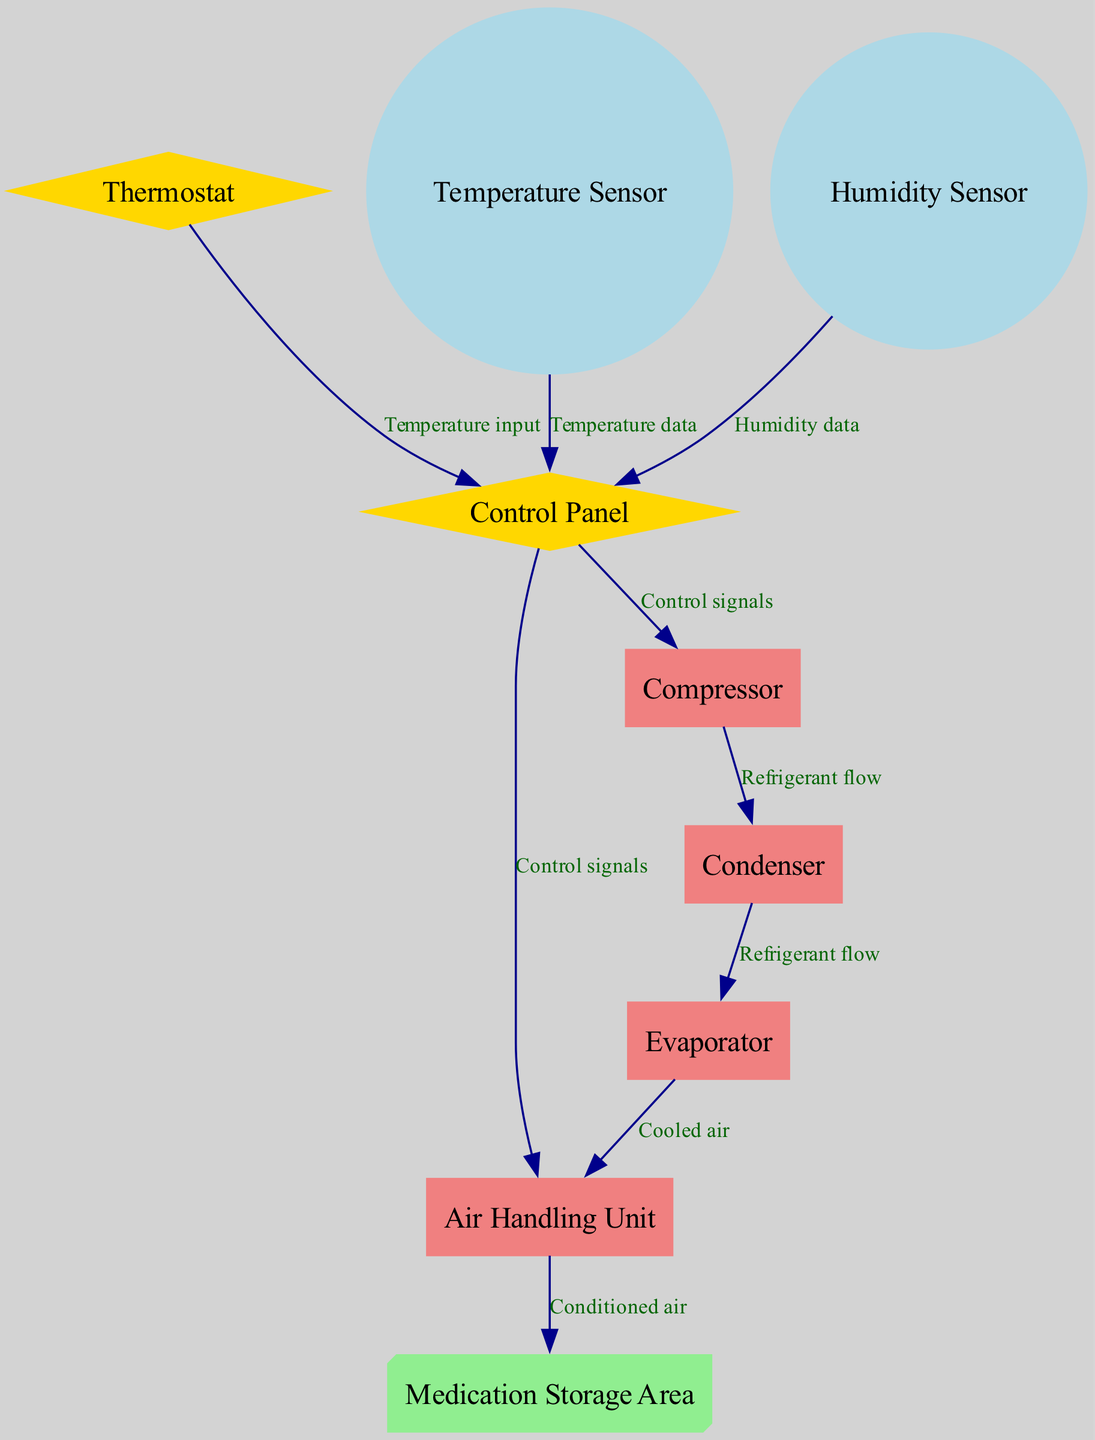What are the shapes of the Thermostat and Control Panel nodes? The Thermostat and Control Panel nodes are both represented as diamond shapes, which typically indicate decision points or controls in a diagram. This can be observed directly from the diagram where specific attributes are assigned to these nodes.
Answer: diamond How many edges are coming out of the Control Panel? The Control Panel node has two edges coming out of it: one towards the Air Handling Unit and one towards the Compressor. This can be counted directly from the diagram.
Answer: 2 What type of sensor is connected to the Control Panel? The Control Panel is connected to two types of sensors: the Temperature Sensor and the Humidity Sensor. The relationship can be determined by following the edges from both sensors to the Control Panel in the diagram.
Answer: Temperature Sensor and Humidity Sensor What is the flow of refrigerant starting from the Compressor? The flow of refrigerant starts at the Compressor and moves to the Condenser, then from the Condenser to the Evaporator. This follows the edges outlined in the diagram, highlighting the path of refrigerant clearly.
Answer: Compressor to Condenser to Evaporator Which node receives conditioned air directly? The Medication Storage Area receives conditioned air directly from the Air Handling Unit, as indicated by the edge connecting these two nodes in the diagram.
Answer: Medication Storage Area How many nodes are there in total? There are a total of nine nodes in the diagram, which can be verified by counting each distinct node listed in the data representation.
Answer: 9 What type of data does the Humidity Sensor send to the Control Panel? The Humidity Sensor sends humidity data to the Control Panel, as indicated by the edge labeled "Humidity data" connecting the two nodes in the diagram.
Answer: Humidity data Which node provides temperature input to the Control Panel? The Thermostat provides temperature input to the Control Panel, as indicated by the edge labeled "Temperature input" connecting the two nodes. This is confirmed by tracing the edge in the diagram.
Answer: Thermostat 